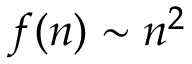Convert formula to latex. <formula><loc_0><loc_0><loc_500><loc_500>f ( n ) \sim n ^ { 2 }</formula> 